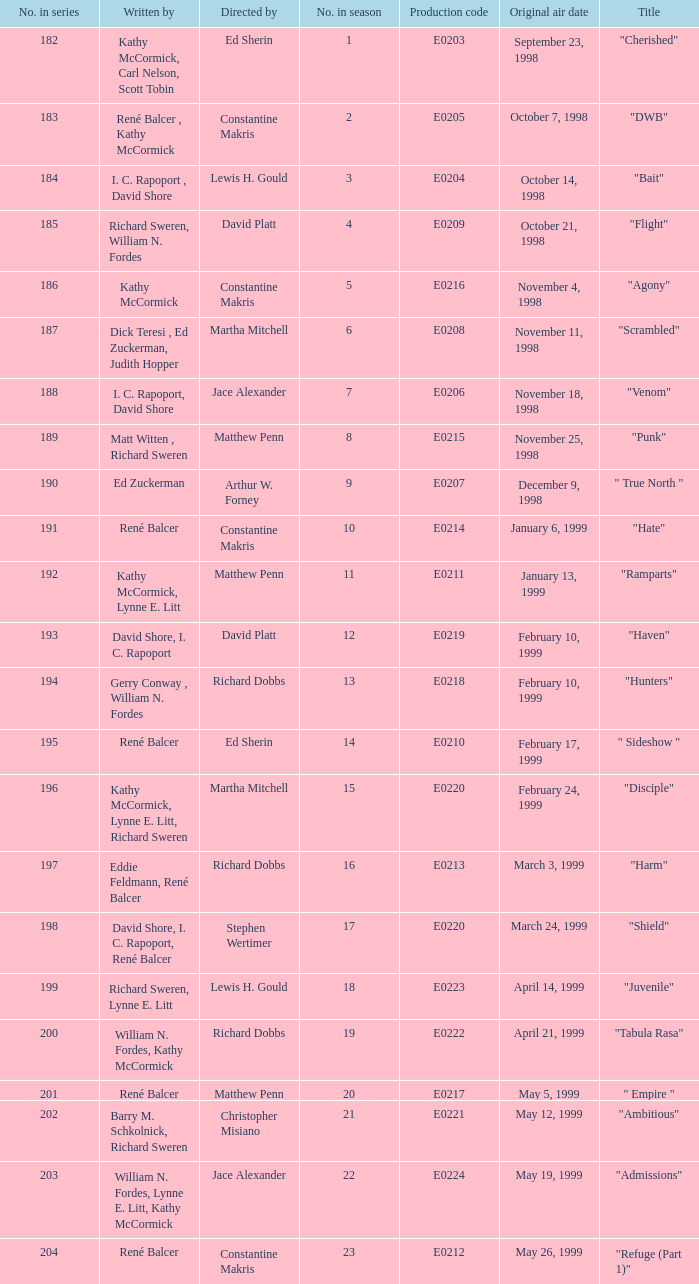On october 21, 1998, what was the title of the episode that first premiered? "Flight". 